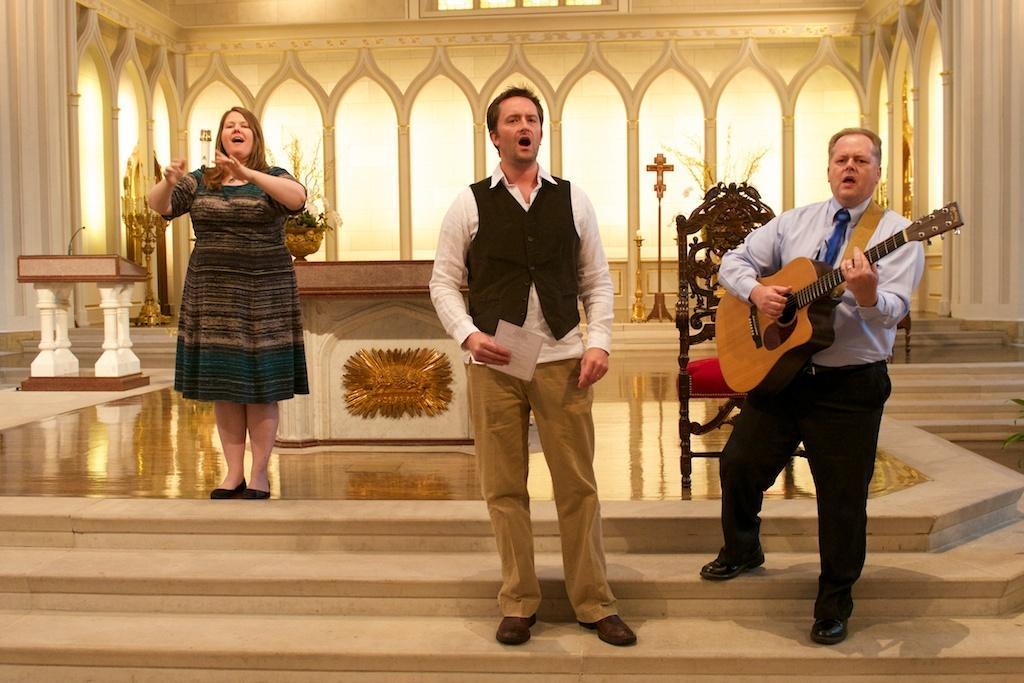In one or two sentences, can you explain what this image depicts? The picture is taken in a closed room where at the right corner one man is standing and playing a guitar, in the middle another person is standing and singing a song and behind him one woman is standing and wearing a dress and behind them there is one podium and flower pot on the podium and chair and big window is present on the wall. 